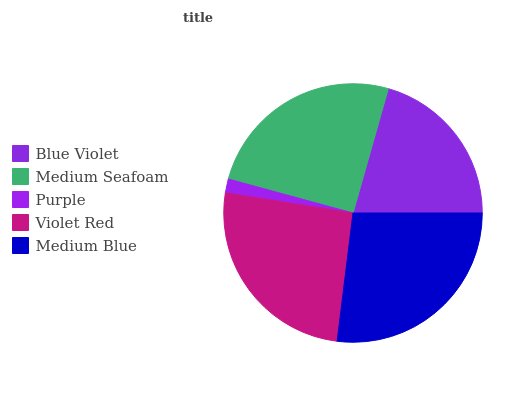Is Purple the minimum?
Answer yes or no. Yes. Is Medium Blue the maximum?
Answer yes or no. Yes. Is Medium Seafoam the minimum?
Answer yes or no. No. Is Medium Seafoam the maximum?
Answer yes or no. No. Is Medium Seafoam greater than Blue Violet?
Answer yes or no. Yes. Is Blue Violet less than Medium Seafoam?
Answer yes or no. Yes. Is Blue Violet greater than Medium Seafoam?
Answer yes or no. No. Is Medium Seafoam less than Blue Violet?
Answer yes or no. No. Is Medium Seafoam the high median?
Answer yes or no. Yes. Is Medium Seafoam the low median?
Answer yes or no. Yes. Is Blue Violet the high median?
Answer yes or no. No. Is Purple the low median?
Answer yes or no. No. 